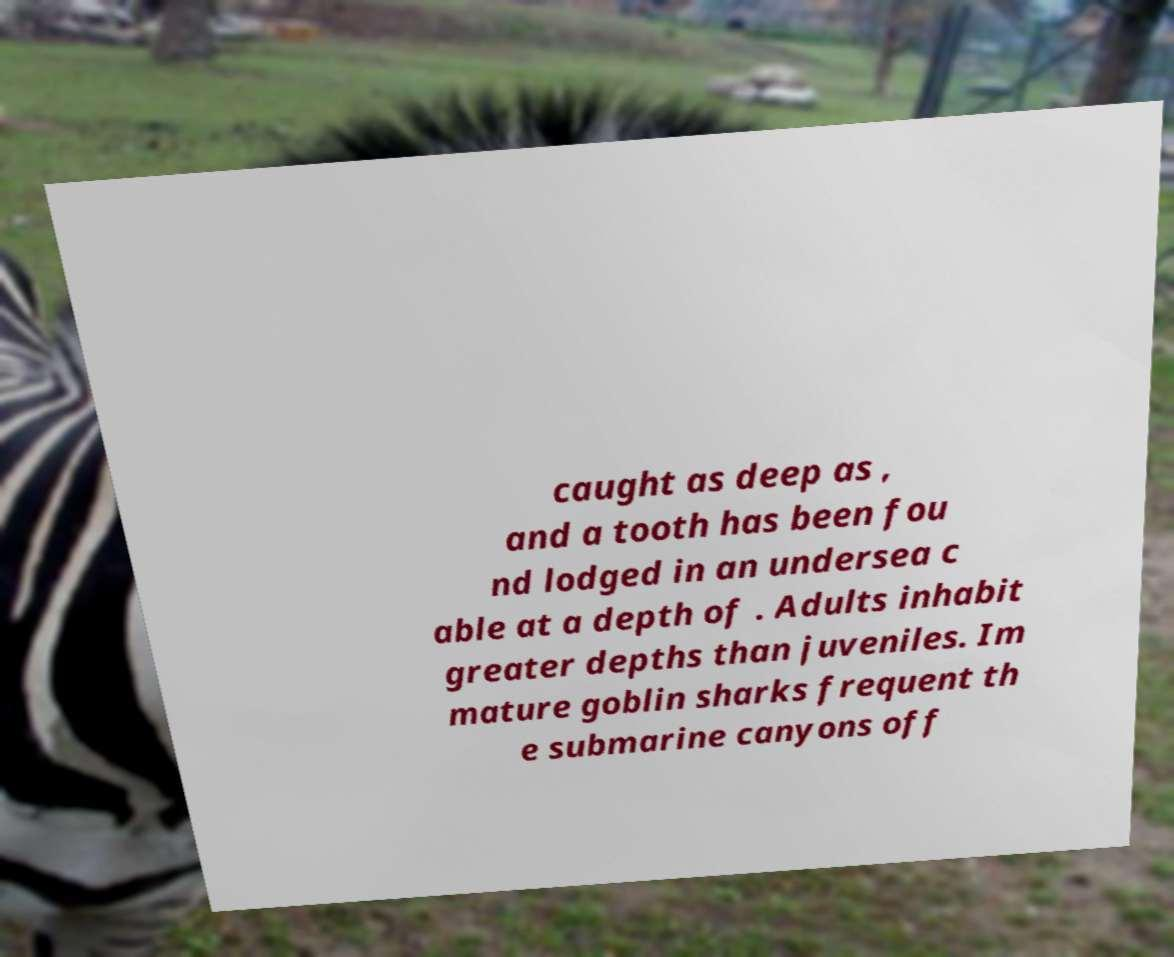Can you read and provide the text displayed in the image?This photo seems to have some interesting text. Can you extract and type it out for me? caught as deep as , and a tooth has been fou nd lodged in an undersea c able at a depth of . Adults inhabit greater depths than juveniles. Im mature goblin sharks frequent th e submarine canyons off 